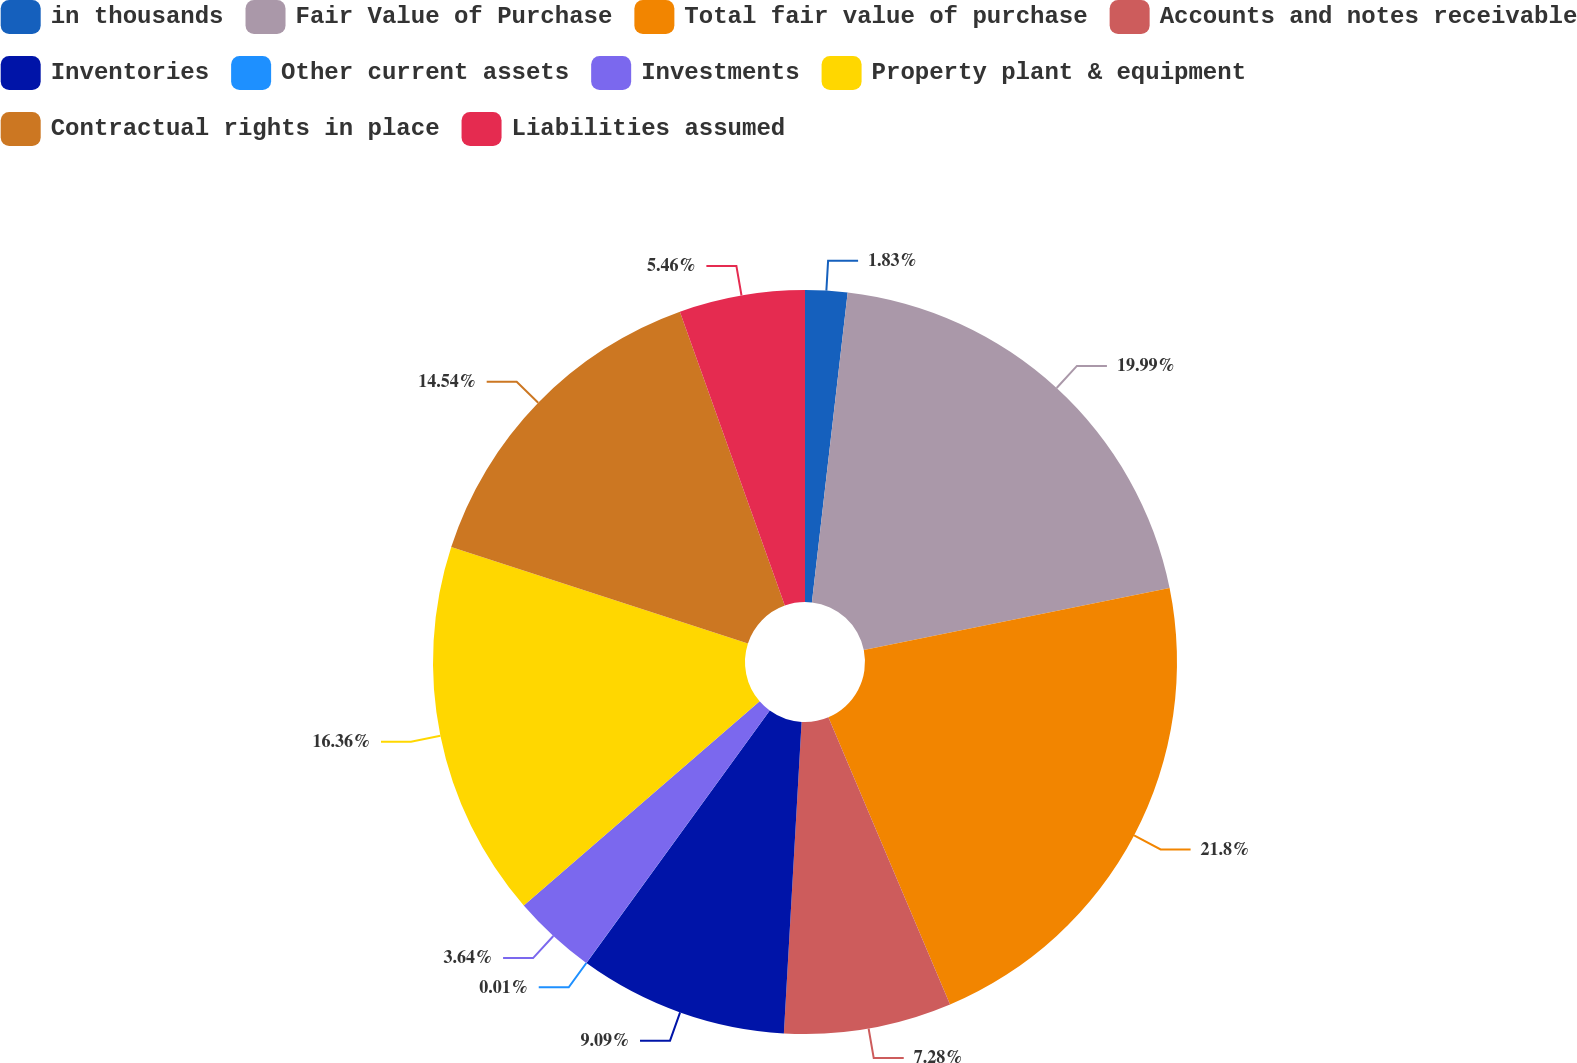<chart> <loc_0><loc_0><loc_500><loc_500><pie_chart><fcel>in thousands<fcel>Fair Value of Purchase<fcel>Total fair value of purchase<fcel>Accounts and notes receivable<fcel>Inventories<fcel>Other current assets<fcel>Investments<fcel>Property plant & equipment<fcel>Contractual rights in place<fcel>Liabilities assumed<nl><fcel>1.83%<fcel>19.99%<fcel>21.81%<fcel>7.28%<fcel>9.09%<fcel>0.01%<fcel>3.64%<fcel>16.36%<fcel>14.54%<fcel>5.46%<nl></chart> 